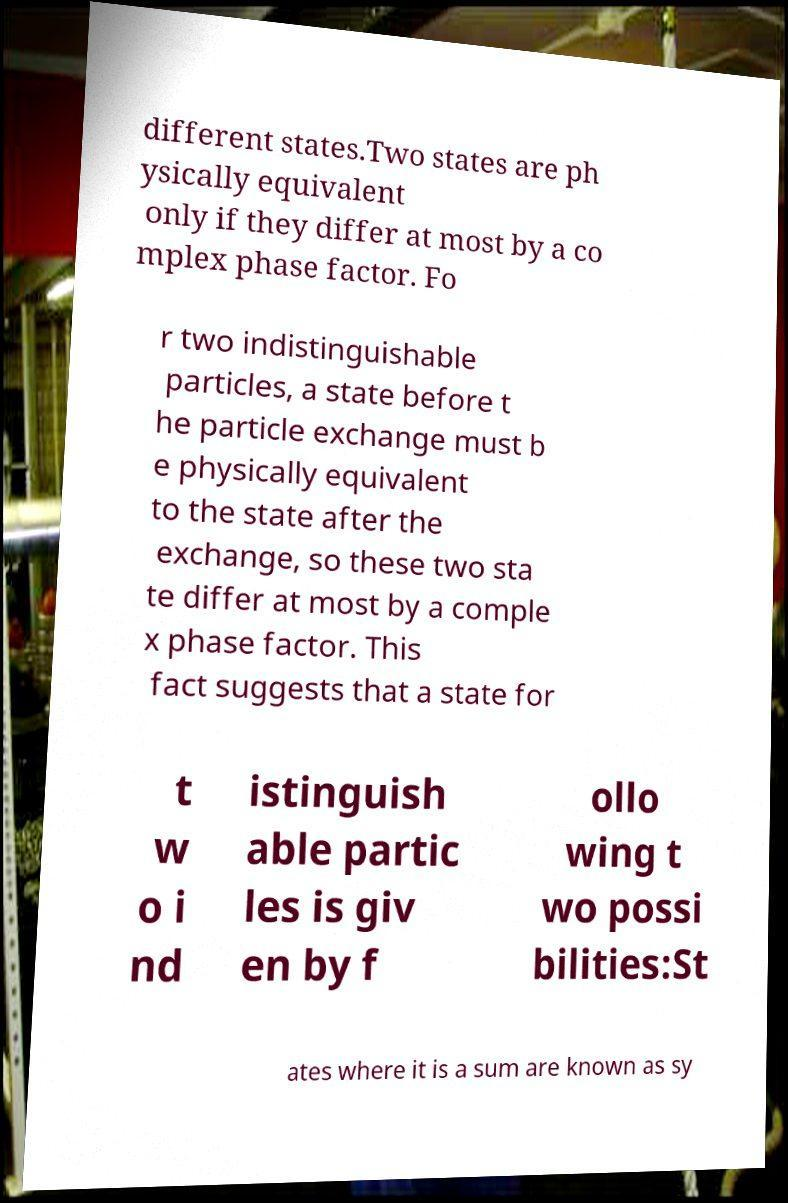There's text embedded in this image that I need extracted. Can you transcribe it verbatim? different states.Two states are ph ysically equivalent only if they differ at most by a co mplex phase factor. Fo r two indistinguishable particles, a state before t he particle exchange must b e physically equivalent to the state after the exchange, so these two sta te differ at most by a comple x phase factor. This fact suggests that a state for t w o i nd istinguish able partic les is giv en by f ollo wing t wo possi bilities:St ates where it is a sum are known as sy 